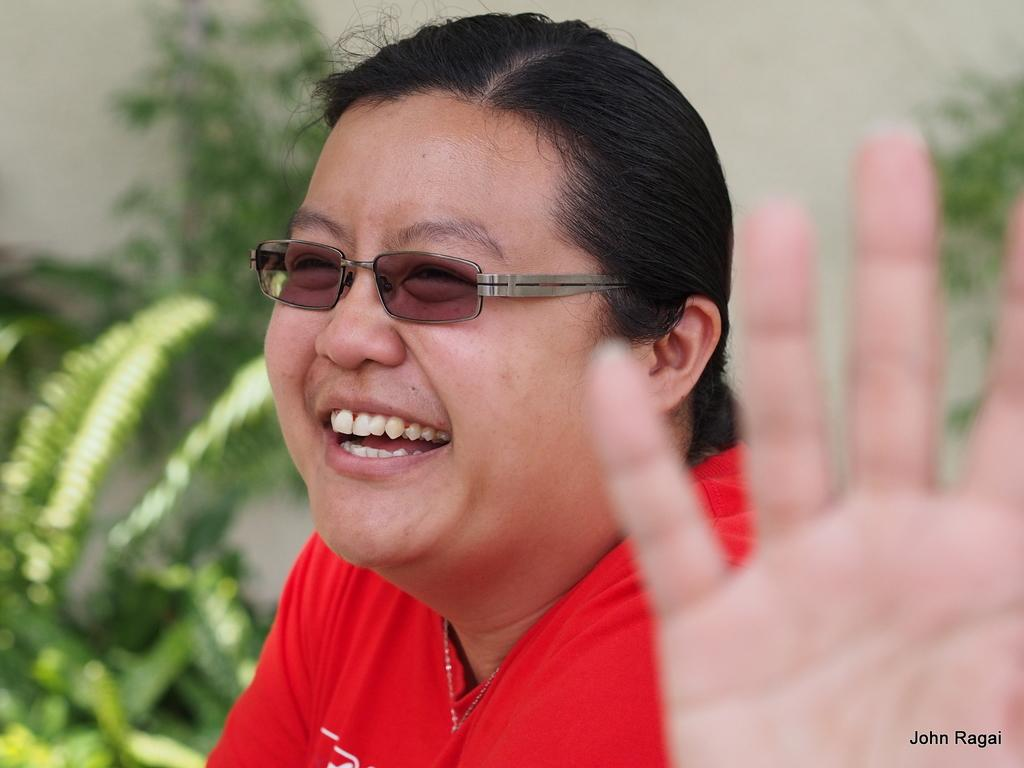Who is present in the image? There is a woman in the image. What is the woman's expression? The woman is smiling. What type of vegetation can be seen in the image? There are plants in the image. What is visible in the background of the image? There is a wall in the background of the image. What type of rifle is the woman holding in the image? There is no rifle present in the image; the woman is simply smiling. How many parcels can be seen in the image? There are no parcels present in the image; it features a woman and plants. 